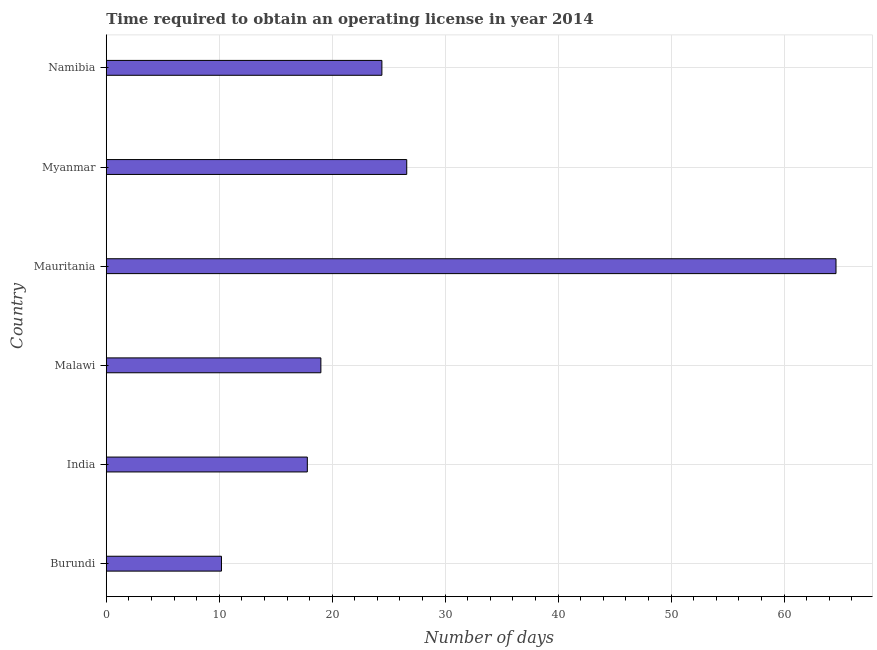What is the title of the graph?
Your answer should be compact. Time required to obtain an operating license in year 2014. What is the label or title of the X-axis?
Provide a short and direct response. Number of days. What is the label or title of the Y-axis?
Provide a short and direct response. Country. What is the number of days to obtain operating license in Namibia?
Your response must be concise. 24.4. Across all countries, what is the maximum number of days to obtain operating license?
Give a very brief answer. 64.6. In which country was the number of days to obtain operating license maximum?
Make the answer very short. Mauritania. In which country was the number of days to obtain operating license minimum?
Your answer should be compact. Burundi. What is the sum of the number of days to obtain operating license?
Make the answer very short. 162.6. What is the difference between the number of days to obtain operating license in Malawi and Myanmar?
Offer a very short reply. -7.6. What is the average number of days to obtain operating license per country?
Your response must be concise. 27.1. What is the median number of days to obtain operating license?
Your answer should be compact. 21.7. In how many countries, is the number of days to obtain operating license greater than 44 days?
Offer a terse response. 1. What is the ratio of the number of days to obtain operating license in India to that in Malawi?
Provide a short and direct response. 0.94. Is the number of days to obtain operating license in India less than that in Mauritania?
Your answer should be very brief. Yes. Is the difference between the number of days to obtain operating license in Burundi and India greater than the difference between any two countries?
Ensure brevity in your answer.  No. What is the difference between the highest and the second highest number of days to obtain operating license?
Give a very brief answer. 38. What is the difference between the highest and the lowest number of days to obtain operating license?
Your answer should be compact. 54.4. In how many countries, is the number of days to obtain operating license greater than the average number of days to obtain operating license taken over all countries?
Keep it short and to the point. 1. What is the Number of days in Burundi?
Provide a succinct answer. 10.2. What is the Number of days in Mauritania?
Provide a succinct answer. 64.6. What is the Number of days of Myanmar?
Keep it short and to the point. 26.6. What is the Number of days in Namibia?
Your answer should be very brief. 24.4. What is the difference between the Number of days in Burundi and India?
Offer a very short reply. -7.6. What is the difference between the Number of days in Burundi and Mauritania?
Provide a succinct answer. -54.4. What is the difference between the Number of days in Burundi and Myanmar?
Your response must be concise. -16.4. What is the difference between the Number of days in India and Mauritania?
Your answer should be compact. -46.8. What is the difference between the Number of days in India and Namibia?
Keep it short and to the point. -6.6. What is the difference between the Number of days in Malawi and Mauritania?
Offer a very short reply. -45.6. What is the difference between the Number of days in Malawi and Myanmar?
Your answer should be very brief. -7.6. What is the difference between the Number of days in Mauritania and Namibia?
Your answer should be very brief. 40.2. What is the difference between the Number of days in Myanmar and Namibia?
Ensure brevity in your answer.  2.2. What is the ratio of the Number of days in Burundi to that in India?
Your answer should be compact. 0.57. What is the ratio of the Number of days in Burundi to that in Malawi?
Ensure brevity in your answer.  0.54. What is the ratio of the Number of days in Burundi to that in Mauritania?
Make the answer very short. 0.16. What is the ratio of the Number of days in Burundi to that in Myanmar?
Your answer should be very brief. 0.38. What is the ratio of the Number of days in Burundi to that in Namibia?
Provide a succinct answer. 0.42. What is the ratio of the Number of days in India to that in Malawi?
Make the answer very short. 0.94. What is the ratio of the Number of days in India to that in Mauritania?
Offer a terse response. 0.28. What is the ratio of the Number of days in India to that in Myanmar?
Provide a short and direct response. 0.67. What is the ratio of the Number of days in India to that in Namibia?
Your answer should be very brief. 0.73. What is the ratio of the Number of days in Malawi to that in Mauritania?
Your response must be concise. 0.29. What is the ratio of the Number of days in Malawi to that in Myanmar?
Your answer should be compact. 0.71. What is the ratio of the Number of days in Malawi to that in Namibia?
Offer a very short reply. 0.78. What is the ratio of the Number of days in Mauritania to that in Myanmar?
Offer a very short reply. 2.43. What is the ratio of the Number of days in Mauritania to that in Namibia?
Your answer should be very brief. 2.65. What is the ratio of the Number of days in Myanmar to that in Namibia?
Provide a short and direct response. 1.09. 